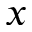Convert formula to latex. <formula><loc_0><loc_0><loc_500><loc_500>x</formula> 